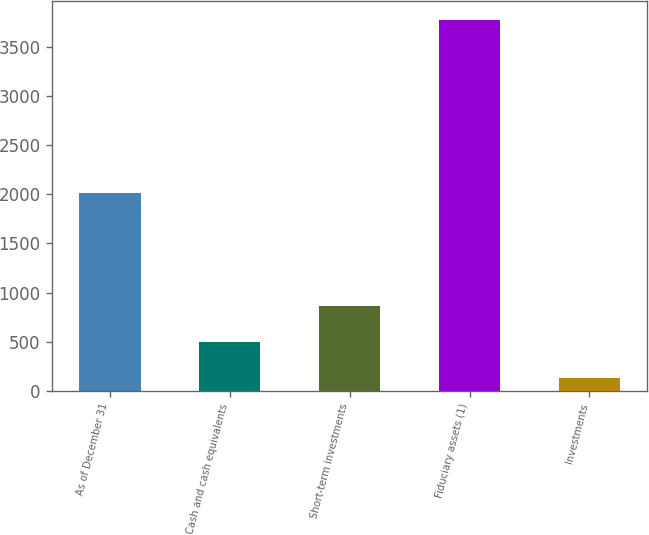Convert chart to OTSL. <chart><loc_0><loc_0><loc_500><loc_500><bar_chart><fcel>As of December 31<fcel>Cash and cash equivalents<fcel>Short-term investments<fcel>Fiduciary assets (1)<fcel>Investments<nl><fcel>2013<fcel>496.6<fcel>861.2<fcel>3778<fcel>132<nl></chart> 